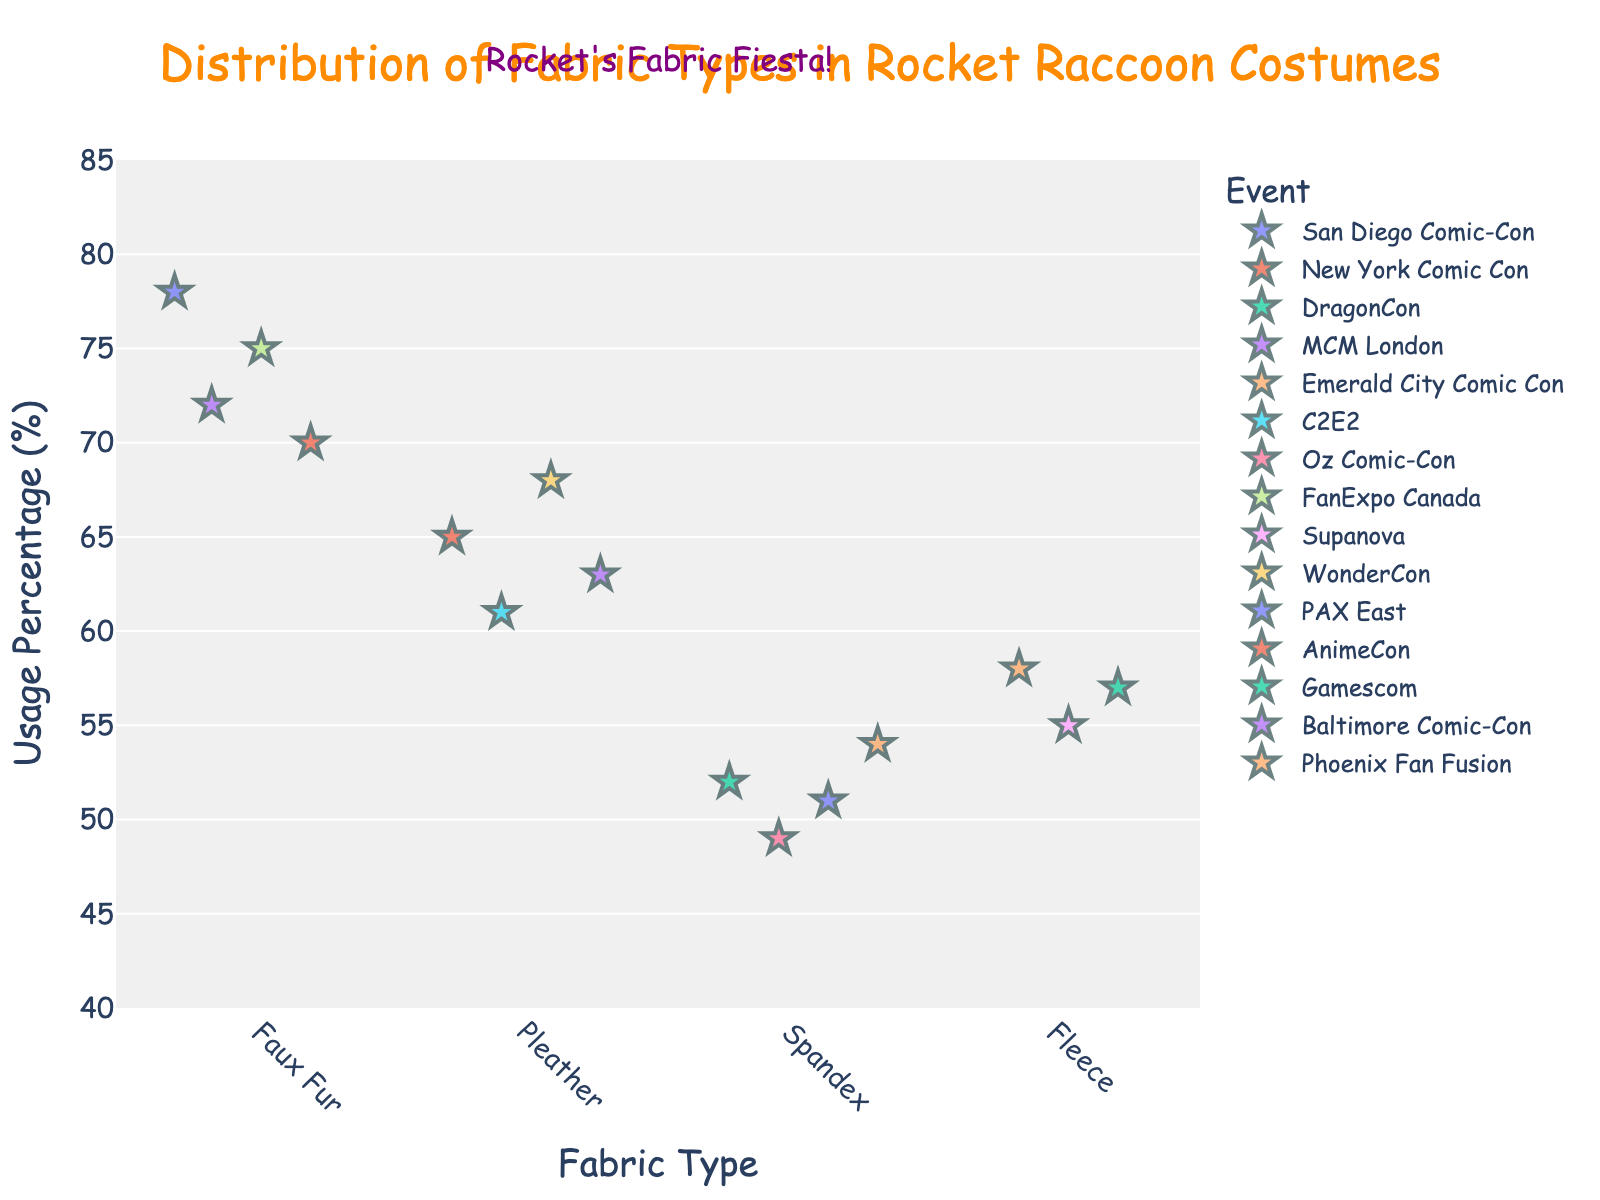What is the title of the plot? The title of the plot is located at the top-center of the figure in a larger font size and color to draw attention.
Answer: Distribution of Fabric Types in Rocket Raccoon Costumes What fabric type is used the most at San Diego Comic-Con? By looking at the points on the x-axis "Faux Fur” and finding the San Diego Comic-Con event, we see its corresponding usage percentage.
Answer: Faux Fur Which fabric type has the highest average usage percentage across events? To determine this, find the average usage percentage for each fabric type and compare them. Faux Fur averages (78+72+75+70)/4, Pleather (65+61+68+63)/4, Spandex (52+49+51+54)/4, Fleece (58+55+57)/3. Calculate the averages and find the highest one.
Answer: Faux Fur How many events used Pleather for the Rocket Raccoon costume? Count the number of points plotted along the Pleather category on the x-axis.
Answer: 4 Which event had the lowest usage percentage for Spandex? On observing the Spandex category along the x-axis, look for the point corresponding to the lowest y-axis value, which represents usage percentage, and then identify the event label.
Answer: Oz Comic-Con Which event had the highest usage percentage for Fleece? Within the Fleece category on the x-axis, find the point corresponding to the highest y-axis value and check the event label associated.
Answer: Emerald City Comic Con What is the median usage percentage of Faux Fur across all events where it was used? To find the median, list all usage percentages for Faux Fur: 78, 72, 75, 70. Sort these values 70, 72, 75, 78 and find the middle value(s). The average of the middle two if even number of observations.
Answer: 73.5 Between DragonCon and WonderCon, which event has a higher usage percentage for its respective fabric type? Compare the usage percentages for Spandex at DragonCon and Pleather at WonderCon. Identify and compare the y-axis values.
Answer: WonderCon What is the range of usage percentages for Faux Fur across events? The range is the difference between the maximum and minimum values of usage percentages for Faux Fur. Values are 78, 72, 75, 70. Calculate 78 - 70.
Answer: 8 Does AnimeCon use the same fabric type as MCM London? Identify the fabric type for both AnimeCon and MCM London on the x-axis and compare if they use the same.
Answer: Yes, Faux Fur 